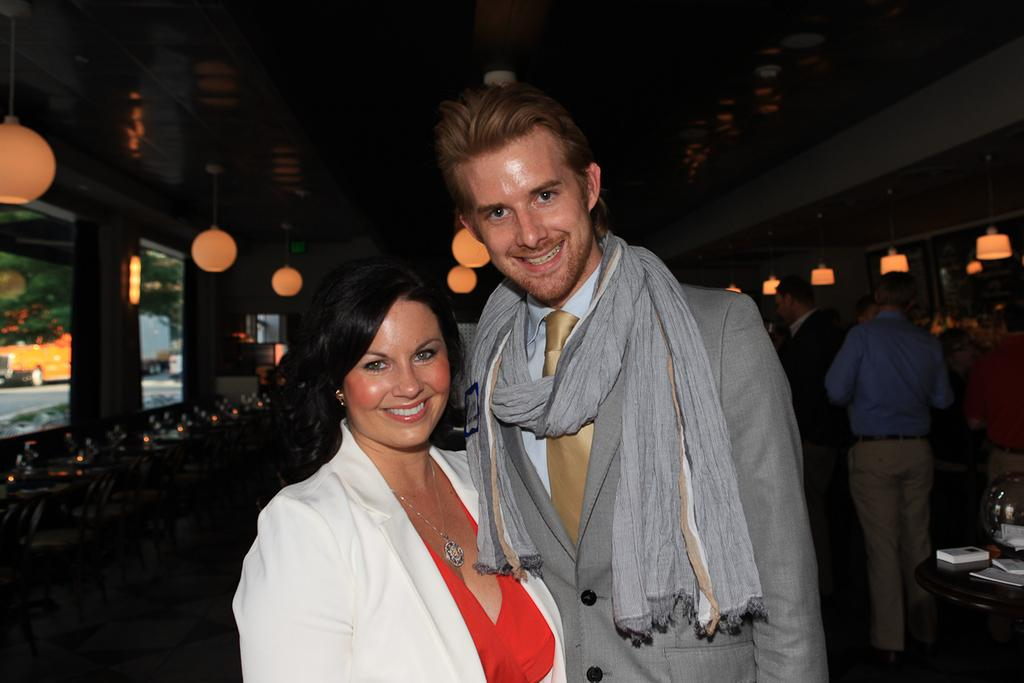How many people are present in the image? There are two people, a man and a woman, present in the image. What are the man and the woman doing in the image? The man and the woman are standing together and smiling. What can be seen in the background of the image? There are lights, people, a ceiling, and other objects visible in the background of the image. What type of brush is being used to apply the jelly to the ceiling in the image? There is no brush or jelly present in the image; the focus is on the man and the woman standing together and smiling. 